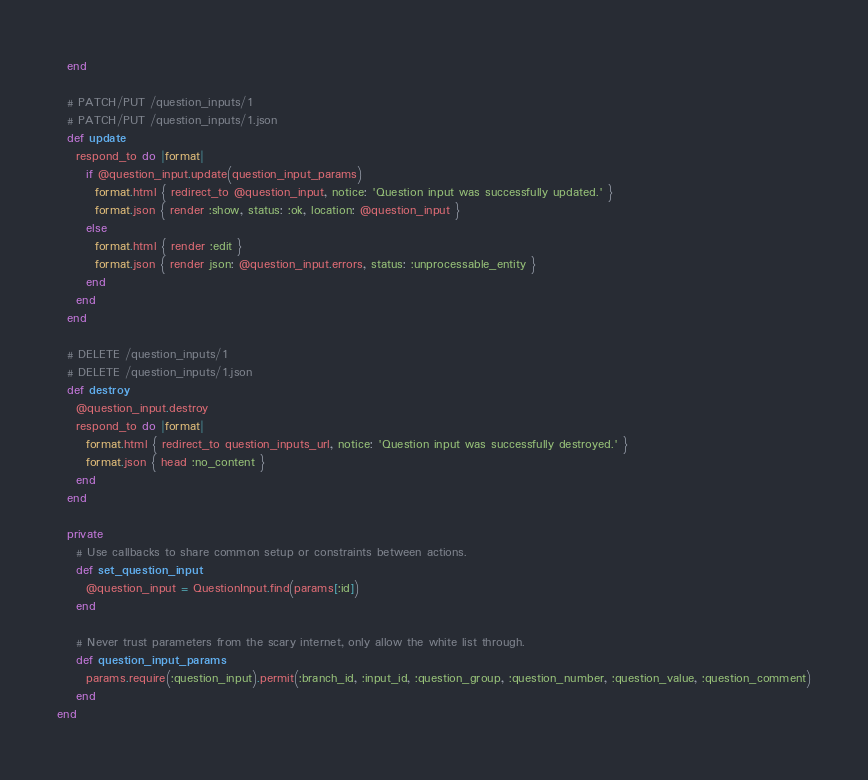<code> <loc_0><loc_0><loc_500><loc_500><_Ruby_>  end

  # PATCH/PUT /question_inputs/1
  # PATCH/PUT /question_inputs/1.json
  def update
    respond_to do |format|
      if @question_input.update(question_input_params)
        format.html { redirect_to @question_input, notice: 'Question input was successfully updated.' }
        format.json { render :show, status: :ok, location: @question_input }
      else
        format.html { render :edit }
        format.json { render json: @question_input.errors, status: :unprocessable_entity }
      end
    end
  end

  # DELETE /question_inputs/1
  # DELETE /question_inputs/1.json
  def destroy
    @question_input.destroy
    respond_to do |format|
      format.html { redirect_to question_inputs_url, notice: 'Question input was successfully destroyed.' }
      format.json { head :no_content }
    end
  end

  private
    # Use callbacks to share common setup or constraints between actions.
    def set_question_input
      @question_input = QuestionInput.find(params[:id])
    end

    # Never trust parameters from the scary internet, only allow the white list through.
    def question_input_params
      params.require(:question_input).permit(:branch_id, :input_id, :question_group, :question_number, :question_value, :question_comment)
    end
end
</code> 